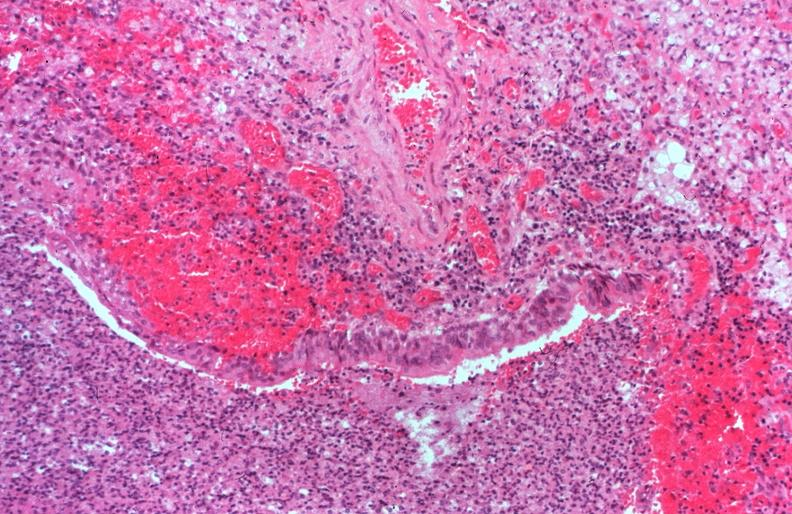does opened larynx show lung, cystic fibrosis?
Answer the question using a single word or phrase. No 